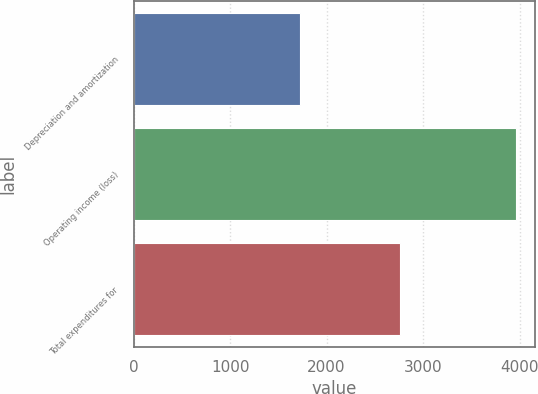<chart> <loc_0><loc_0><loc_500><loc_500><bar_chart><fcel>Depreciation and amortization<fcel>Operating income (loss)<fcel>Total expenditures for<nl><fcel>1720<fcel>3957<fcel>2757<nl></chart> 